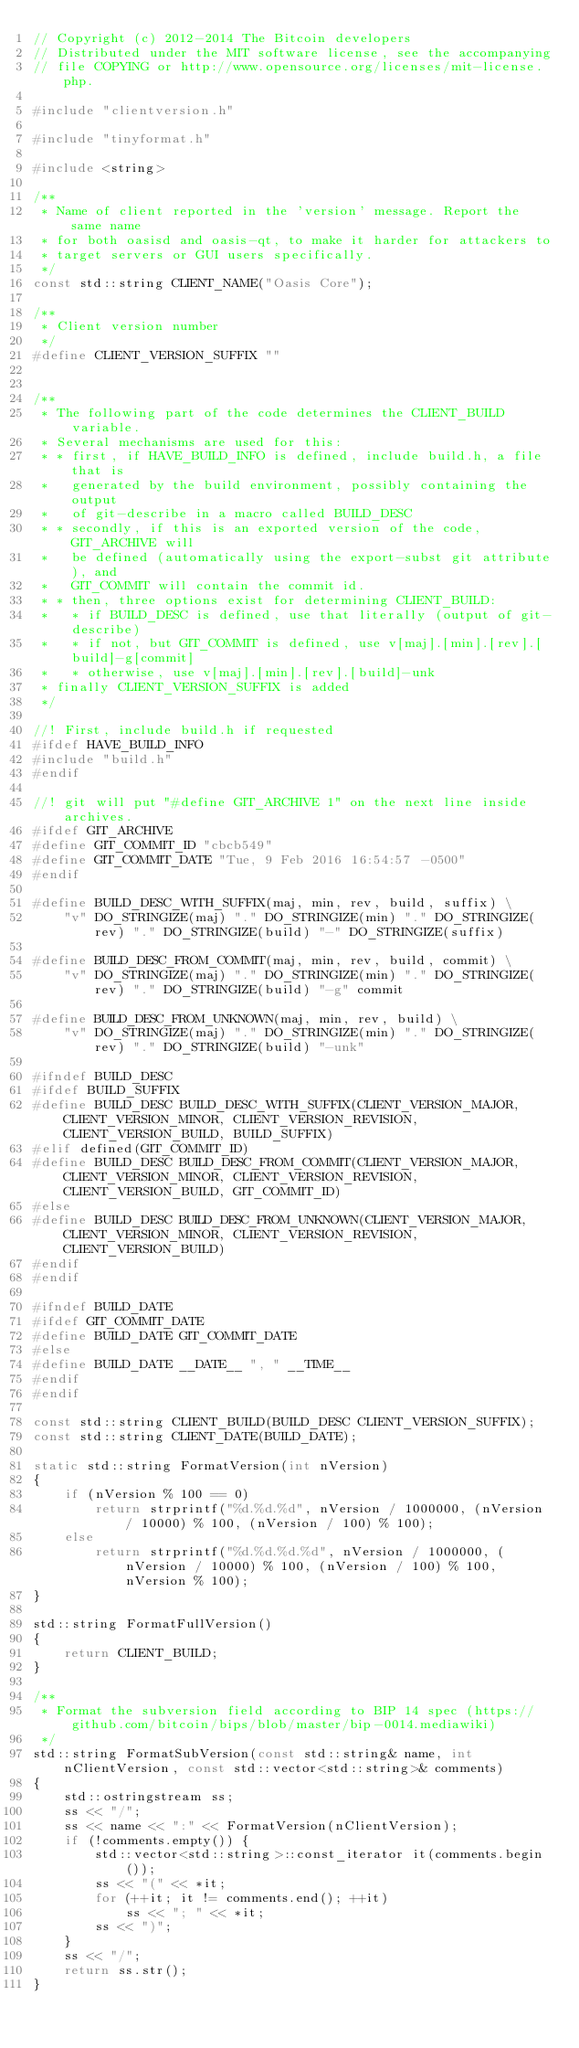Convert code to text. <code><loc_0><loc_0><loc_500><loc_500><_C++_>// Copyright (c) 2012-2014 The Bitcoin developers
// Distributed under the MIT software license, see the accompanying
// file COPYING or http://www.opensource.org/licenses/mit-license.php.

#include "clientversion.h"

#include "tinyformat.h"

#include <string>

/**
 * Name of client reported in the 'version' message. Report the same name
 * for both oasisd and oasis-qt, to make it harder for attackers to
 * target servers or GUI users specifically.
 */
const std::string CLIENT_NAME("Oasis Core");

/**
 * Client version number
 */
#define CLIENT_VERSION_SUFFIX ""


/**
 * The following part of the code determines the CLIENT_BUILD variable.
 * Several mechanisms are used for this:
 * * first, if HAVE_BUILD_INFO is defined, include build.h, a file that is
 *   generated by the build environment, possibly containing the output
 *   of git-describe in a macro called BUILD_DESC
 * * secondly, if this is an exported version of the code, GIT_ARCHIVE will
 *   be defined (automatically using the export-subst git attribute), and
 *   GIT_COMMIT will contain the commit id.
 * * then, three options exist for determining CLIENT_BUILD:
 *   * if BUILD_DESC is defined, use that literally (output of git-describe)
 *   * if not, but GIT_COMMIT is defined, use v[maj].[min].[rev].[build]-g[commit]
 *   * otherwise, use v[maj].[min].[rev].[build]-unk
 * finally CLIENT_VERSION_SUFFIX is added
 */

//! First, include build.h if requested
#ifdef HAVE_BUILD_INFO
#include "build.h"
#endif

//! git will put "#define GIT_ARCHIVE 1" on the next line inside archives.
#ifdef GIT_ARCHIVE
#define GIT_COMMIT_ID "cbcb549"
#define GIT_COMMIT_DATE "Tue, 9 Feb 2016 16:54:57 -0500"
#endif

#define BUILD_DESC_WITH_SUFFIX(maj, min, rev, build, suffix) \
    "v" DO_STRINGIZE(maj) "." DO_STRINGIZE(min) "." DO_STRINGIZE(rev) "." DO_STRINGIZE(build) "-" DO_STRINGIZE(suffix)

#define BUILD_DESC_FROM_COMMIT(maj, min, rev, build, commit) \
    "v" DO_STRINGIZE(maj) "." DO_STRINGIZE(min) "." DO_STRINGIZE(rev) "." DO_STRINGIZE(build) "-g" commit

#define BUILD_DESC_FROM_UNKNOWN(maj, min, rev, build) \
    "v" DO_STRINGIZE(maj) "." DO_STRINGIZE(min) "." DO_STRINGIZE(rev) "." DO_STRINGIZE(build) "-unk"

#ifndef BUILD_DESC
#ifdef BUILD_SUFFIX
#define BUILD_DESC BUILD_DESC_WITH_SUFFIX(CLIENT_VERSION_MAJOR, CLIENT_VERSION_MINOR, CLIENT_VERSION_REVISION, CLIENT_VERSION_BUILD, BUILD_SUFFIX)
#elif defined(GIT_COMMIT_ID)
#define BUILD_DESC BUILD_DESC_FROM_COMMIT(CLIENT_VERSION_MAJOR, CLIENT_VERSION_MINOR, CLIENT_VERSION_REVISION, CLIENT_VERSION_BUILD, GIT_COMMIT_ID)
#else
#define BUILD_DESC BUILD_DESC_FROM_UNKNOWN(CLIENT_VERSION_MAJOR, CLIENT_VERSION_MINOR, CLIENT_VERSION_REVISION, CLIENT_VERSION_BUILD)
#endif
#endif

#ifndef BUILD_DATE
#ifdef GIT_COMMIT_DATE
#define BUILD_DATE GIT_COMMIT_DATE
#else
#define BUILD_DATE __DATE__ ", " __TIME__
#endif
#endif

const std::string CLIENT_BUILD(BUILD_DESC CLIENT_VERSION_SUFFIX);
const std::string CLIENT_DATE(BUILD_DATE);

static std::string FormatVersion(int nVersion)
{
    if (nVersion % 100 == 0)
        return strprintf("%d.%d.%d", nVersion / 1000000, (nVersion / 10000) % 100, (nVersion / 100) % 100);
    else
        return strprintf("%d.%d.%d.%d", nVersion / 1000000, (nVersion / 10000) % 100, (nVersion / 100) % 100, nVersion % 100);
}

std::string FormatFullVersion()
{
    return CLIENT_BUILD;
}

/** 
 * Format the subversion field according to BIP 14 spec (https://github.com/bitcoin/bips/blob/master/bip-0014.mediawiki) 
 */
std::string FormatSubVersion(const std::string& name, int nClientVersion, const std::vector<std::string>& comments)
{
    std::ostringstream ss;
    ss << "/";
    ss << name << ":" << FormatVersion(nClientVersion);
    if (!comments.empty()) {
        std::vector<std::string>::const_iterator it(comments.begin());
        ss << "(" << *it;
        for (++it; it != comments.end(); ++it)
            ss << "; " << *it;
        ss << ")";
    }
    ss << "/";
    return ss.str();
}
</code> 